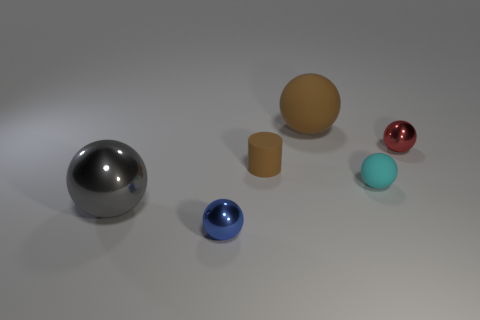Subtract all large gray spheres. How many spheres are left? 4 Subtract all red balls. How many balls are left? 4 Add 4 blue matte objects. How many objects exist? 10 Subtract all purple balls. Subtract all blue cylinders. How many balls are left? 5 Subtract all cylinders. How many objects are left? 5 Add 5 large shiny objects. How many large shiny objects are left? 6 Add 6 cylinders. How many cylinders exist? 7 Subtract 1 gray balls. How many objects are left? 5 Subtract all small cyan rubber balls. Subtract all tiny cyan rubber things. How many objects are left? 4 